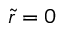Convert formula to latex. <formula><loc_0><loc_0><loc_500><loc_500>\tilde { r } = 0</formula> 